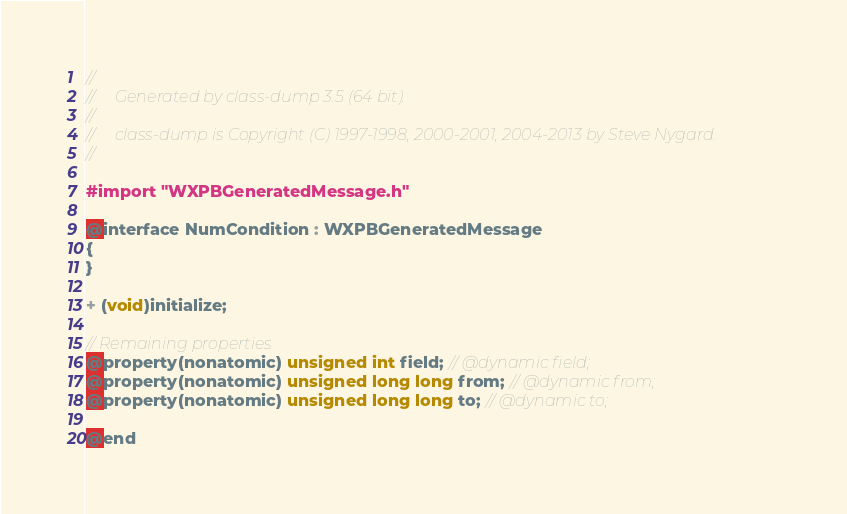Convert code to text. <code><loc_0><loc_0><loc_500><loc_500><_C_>//
//     Generated by class-dump 3.5 (64 bit).
//
//     class-dump is Copyright (C) 1997-1998, 2000-2001, 2004-2013 by Steve Nygard.
//

#import "WXPBGeneratedMessage.h"

@interface NumCondition : WXPBGeneratedMessage
{
}

+ (void)initialize;

// Remaining properties
@property(nonatomic) unsigned int field; // @dynamic field;
@property(nonatomic) unsigned long long from; // @dynamic from;
@property(nonatomic) unsigned long long to; // @dynamic to;

@end

</code> 